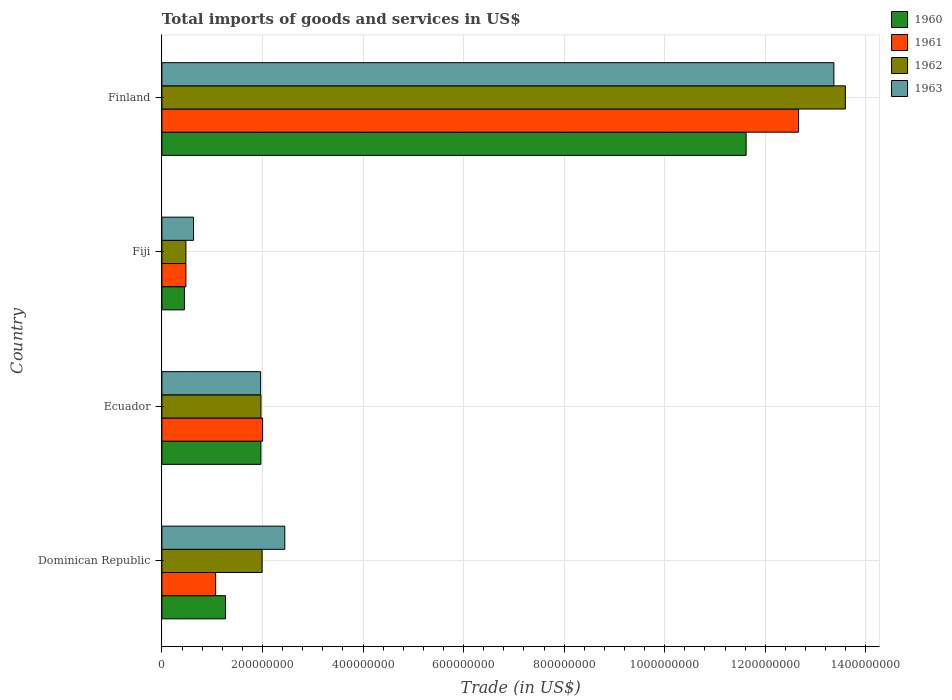How many groups of bars are there?
Offer a very short reply. 4. What is the total imports of goods and services in 1960 in Finland?
Give a very brief answer. 1.16e+09. Across all countries, what is the maximum total imports of goods and services in 1960?
Give a very brief answer. 1.16e+09. Across all countries, what is the minimum total imports of goods and services in 1961?
Your answer should be very brief. 4.77e+07. In which country was the total imports of goods and services in 1962 minimum?
Make the answer very short. Fiji. What is the total total imports of goods and services in 1961 in the graph?
Provide a short and direct response. 1.62e+09. What is the difference between the total imports of goods and services in 1960 in Dominican Republic and that in Finland?
Make the answer very short. -1.04e+09. What is the difference between the total imports of goods and services in 1960 in Fiji and the total imports of goods and services in 1961 in Ecuador?
Your answer should be compact. -1.55e+08. What is the average total imports of goods and services in 1960 per country?
Offer a very short reply. 3.83e+08. What is the difference between the total imports of goods and services in 1960 and total imports of goods and services in 1961 in Ecuador?
Provide a short and direct response. -3.37e+06. What is the ratio of the total imports of goods and services in 1961 in Ecuador to that in Fiji?
Offer a terse response. 4.2. Is the total imports of goods and services in 1962 in Fiji less than that in Finland?
Your answer should be compact. Yes. What is the difference between the highest and the second highest total imports of goods and services in 1962?
Your answer should be compact. 1.16e+09. What is the difference between the highest and the lowest total imports of goods and services in 1960?
Your answer should be very brief. 1.12e+09. In how many countries, is the total imports of goods and services in 1960 greater than the average total imports of goods and services in 1960 taken over all countries?
Give a very brief answer. 1. Is the sum of the total imports of goods and services in 1961 in Dominican Republic and Ecuador greater than the maximum total imports of goods and services in 1962 across all countries?
Keep it short and to the point. No. What does the 2nd bar from the bottom in Finland represents?
Offer a very short reply. 1961. How many bars are there?
Give a very brief answer. 16. Are all the bars in the graph horizontal?
Offer a terse response. Yes. How many countries are there in the graph?
Make the answer very short. 4. What is the difference between two consecutive major ticks on the X-axis?
Provide a short and direct response. 2.00e+08. Does the graph contain grids?
Make the answer very short. Yes. Where does the legend appear in the graph?
Give a very brief answer. Top right. What is the title of the graph?
Provide a short and direct response. Total imports of goods and services in US$. What is the label or title of the X-axis?
Make the answer very short. Trade (in US$). What is the Trade (in US$) of 1960 in Dominican Republic?
Offer a terse response. 1.26e+08. What is the Trade (in US$) of 1961 in Dominican Republic?
Provide a short and direct response. 1.07e+08. What is the Trade (in US$) in 1962 in Dominican Republic?
Give a very brief answer. 1.99e+08. What is the Trade (in US$) of 1963 in Dominican Republic?
Offer a terse response. 2.44e+08. What is the Trade (in US$) in 1960 in Ecuador?
Give a very brief answer. 1.97e+08. What is the Trade (in US$) of 1961 in Ecuador?
Your answer should be very brief. 2.00e+08. What is the Trade (in US$) of 1962 in Ecuador?
Ensure brevity in your answer.  1.97e+08. What is the Trade (in US$) in 1963 in Ecuador?
Provide a short and direct response. 1.96e+08. What is the Trade (in US$) of 1960 in Fiji?
Your response must be concise. 4.48e+07. What is the Trade (in US$) of 1961 in Fiji?
Provide a short and direct response. 4.77e+07. What is the Trade (in US$) in 1962 in Fiji?
Keep it short and to the point. 4.77e+07. What is the Trade (in US$) of 1963 in Fiji?
Provide a short and direct response. 6.30e+07. What is the Trade (in US$) of 1960 in Finland?
Ensure brevity in your answer.  1.16e+09. What is the Trade (in US$) in 1961 in Finland?
Offer a terse response. 1.27e+09. What is the Trade (in US$) of 1962 in Finland?
Offer a very short reply. 1.36e+09. What is the Trade (in US$) in 1963 in Finland?
Ensure brevity in your answer.  1.34e+09. Across all countries, what is the maximum Trade (in US$) in 1960?
Your answer should be compact. 1.16e+09. Across all countries, what is the maximum Trade (in US$) of 1961?
Offer a terse response. 1.27e+09. Across all countries, what is the maximum Trade (in US$) of 1962?
Offer a very short reply. 1.36e+09. Across all countries, what is the maximum Trade (in US$) in 1963?
Make the answer very short. 1.34e+09. Across all countries, what is the minimum Trade (in US$) in 1960?
Ensure brevity in your answer.  4.48e+07. Across all countries, what is the minimum Trade (in US$) in 1961?
Offer a terse response. 4.77e+07. Across all countries, what is the minimum Trade (in US$) of 1962?
Make the answer very short. 4.77e+07. Across all countries, what is the minimum Trade (in US$) in 1963?
Ensure brevity in your answer.  6.30e+07. What is the total Trade (in US$) in 1960 in the graph?
Keep it short and to the point. 1.53e+09. What is the total Trade (in US$) in 1961 in the graph?
Offer a terse response. 1.62e+09. What is the total Trade (in US$) of 1962 in the graph?
Offer a terse response. 1.80e+09. What is the total Trade (in US$) of 1963 in the graph?
Make the answer very short. 1.84e+09. What is the difference between the Trade (in US$) in 1960 in Dominican Republic and that in Ecuador?
Keep it short and to the point. -7.04e+07. What is the difference between the Trade (in US$) in 1961 in Dominican Republic and that in Ecuador?
Ensure brevity in your answer.  -9.34e+07. What is the difference between the Trade (in US$) in 1962 in Dominican Republic and that in Ecuador?
Your answer should be compact. 2.27e+06. What is the difference between the Trade (in US$) in 1963 in Dominican Republic and that in Ecuador?
Provide a succinct answer. 4.80e+07. What is the difference between the Trade (in US$) in 1960 in Dominican Republic and that in Fiji?
Make the answer very short. 8.17e+07. What is the difference between the Trade (in US$) in 1961 in Dominican Republic and that in Fiji?
Keep it short and to the point. 5.92e+07. What is the difference between the Trade (in US$) of 1962 in Dominican Republic and that in Fiji?
Make the answer very short. 1.52e+08. What is the difference between the Trade (in US$) of 1963 in Dominican Republic and that in Fiji?
Provide a succinct answer. 1.81e+08. What is the difference between the Trade (in US$) in 1960 in Dominican Republic and that in Finland?
Your answer should be very brief. -1.04e+09. What is the difference between the Trade (in US$) in 1961 in Dominican Republic and that in Finland?
Keep it short and to the point. -1.16e+09. What is the difference between the Trade (in US$) in 1962 in Dominican Republic and that in Finland?
Your response must be concise. -1.16e+09. What is the difference between the Trade (in US$) of 1963 in Dominican Republic and that in Finland?
Offer a very short reply. -1.09e+09. What is the difference between the Trade (in US$) of 1960 in Ecuador and that in Fiji?
Provide a short and direct response. 1.52e+08. What is the difference between the Trade (in US$) of 1961 in Ecuador and that in Fiji?
Ensure brevity in your answer.  1.53e+08. What is the difference between the Trade (in US$) of 1962 in Ecuador and that in Fiji?
Ensure brevity in your answer.  1.49e+08. What is the difference between the Trade (in US$) in 1963 in Ecuador and that in Fiji?
Offer a terse response. 1.33e+08. What is the difference between the Trade (in US$) of 1960 in Ecuador and that in Finland?
Your answer should be compact. -9.65e+08. What is the difference between the Trade (in US$) of 1961 in Ecuador and that in Finland?
Give a very brief answer. -1.07e+09. What is the difference between the Trade (in US$) in 1962 in Ecuador and that in Finland?
Make the answer very short. -1.16e+09. What is the difference between the Trade (in US$) in 1963 in Ecuador and that in Finland?
Your response must be concise. -1.14e+09. What is the difference between the Trade (in US$) of 1960 in Fiji and that in Finland?
Offer a very short reply. -1.12e+09. What is the difference between the Trade (in US$) of 1961 in Fiji and that in Finland?
Offer a very short reply. -1.22e+09. What is the difference between the Trade (in US$) of 1962 in Fiji and that in Finland?
Provide a short and direct response. -1.31e+09. What is the difference between the Trade (in US$) of 1963 in Fiji and that in Finland?
Give a very brief answer. -1.27e+09. What is the difference between the Trade (in US$) in 1960 in Dominican Republic and the Trade (in US$) in 1961 in Ecuador?
Your answer should be compact. -7.38e+07. What is the difference between the Trade (in US$) of 1960 in Dominican Republic and the Trade (in US$) of 1962 in Ecuador?
Keep it short and to the point. -7.05e+07. What is the difference between the Trade (in US$) of 1960 in Dominican Republic and the Trade (in US$) of 1963 in Ecuador?
Your response must be concise. -6.99e+07. What is the difference between the Trade (in US$) in 1961 in Dominican Republic and the Trade (in US$) in 1962 in Ecuador?
Give a very brief answer. -9.01e+07. What is the difference between the Trade (in US$) of 1961 in Dominican Republic and the Trade (in US$) of 1963 in Ecuador?
Keep it short and to the point. -8.95e+07. What is the difference between the Trade (in US$) of 1962 in Dominican Republic and the Trade (in US$) of 1963 in Ecuador?
Your answer should be compact. 2.94e+06. What is the difference between the Trade (in US$) of 1960 in Dominican Republic and the Trade (in US$) of 1961 in Fiji?
Ensure brevity in your answer.  7.88e+07. What is the difference between the Trade (in US$) in 1960 in Dominican Republic and the Trade (in US$) in 1962 in Fiji?
Your answer should be compact. 7.88e+07. What is the difference between the Trade (in US$) of 1960 in Dominican Republic and the Trade (in US$) of 1963 in Fiji?
Provide a succinct answer. 6.35e+07. What is the difference between the Trade (in US$) of 1961 in Dominican Republic and the Trade (in US$) of 1962 in Fiji?
Give a very brief answer. 5.92e+07. What is the difference between the Trade (in US$) of 1961 in Dominican Republic and the Trade (in US$) of 1963 in Fiji?
Offer a terse response. 4.39e+07. What is the difference between the Trade (in US$) in 1962 in Dominican Republic and the Trade (in US$) in 1963 in Fiji?
Make the answer very short. 1.36e+08. What is the difference between the Trade (in US$) in 1960 in Dominican Republic and the Trade (in US$) in 1961 in Finland?
Provide a succinct answer. -1.14e+09. What is the difference between the Trade (in US$) of 1960 in Dominican Republic and the Trade (in US$) of 1962 in Finland?
Offer a very short reply. -1.23e+09. What is the difference between the Trade (in US$) in 1960 in Dominican Republic and the Trade (in US$) in 1963 in Finland?
Provide a short and direct response. -1.21e+09. What is the difference between the Trade (in US$) in 1961 in Dominican Republic and the Trade (in US$) in 1962 in Finland?
Keep it short and to the point. -1.25e+09. What is the difference between the Trade (in US$) in 1961 in Dominican Republic and the Trade (in US$) in 1963 in Finland?
Your response must be concise. -1.23e+09. What is the difference between the Trade (in US$) in 1962 in Dominican Republic and the Trade (in US$) in 1963 in Finland?
Ensure brevity in your answer.  -1.14e+09. What is the difference between the Trade (in US$) of 1960 in Ecuador and the Trade (in US$) of 1961 in Fiji?
Your answer should be compact. 1.49e+08. What is the difference between the Trade (in US$) of 1960 in Ecuador and the Trade (in US$) of 1962 in Fiji?
Your answer should be very brief. 1.49e+08. What is the difference between the Trade (in US$) of 1960 in Ecuador and the Trade (in US$) of 1963 in Fiji?
Your answer should be compact. 1.34e+08. What is the difference between the Trade (in US$) of 1961 in Ecuador and the Trade (in US$) of 1962 in Fiji?
Keep it short and to the point. 1.53e+08. What is the difference between the Trade (in US$) in 1961 in Ecuador and the Trade (in US$) in 1963 in Fiji?
Make the answer very short. 1.37e+08. What is the difference between the Trade (in US$) of 1962 in Ecuador and the Trade (in US$) of 1963 in Fiji?
Ensure brevity in your answer.  1.34e+08. What is the difference between the Trade (in US$) of 1960 in Ecuador and the Trade (in US$) of 1961 in Finland?
Your answer should be compact. -1.07e+09. What is the difference between the Trade (in US$) of 1960 in Ecuador and the Trade (in US$) of 1962 in Finland?
Ensure brevity in your answer.  -1.16e+09. What is the difference between the Trade (in US$) in 1960 in Ecuador and the Trade (in US$) in 1963 in Finland?
Provide a short and direct response. -1.14e+09. What is the difference between the Trade (in US$) in 1961 in Ecuador and the Trade (in US$) in 1962 in Finland?
Give a very brief answer. -1.16e+09. What is the difference between the Trade (in US$) of 1961 in Ecuador and the Trade (in US$) of 1963 in Finland?
Offer a terse response. -1.14e+09. What is the difference between the Trade (in US$) in 1962 in Ecuador and the Trade (in US$) in 1963 in Finland?
Provide a succinct answer. -1.14e+09. What is the difference between the Trade (in US$) of 1960 in Fiji and the Trade (in US$) of 1961 in Finland?
Make the answer very short. -1.22e+09. What is the difference between the Trade (in US$) in 1960 in Fiji and the Trade (in US$) in 1962 in Finland?
Your response must be concise. -1.31e+09. What is the difference between the Trade (in US$) of 1960 in Fiji and the Trade (in US$) of 1963 in Finland?
Your response must be concise. -1.29e+09. What is the difference between the Trade (in US$) in 1961 in Fiji and the Trade (in US$) in 1962 in Finland?
Give a very brief answer. -1.31e+09. What is the difference between the Trade (in US$) of 1961 in Fiji and the Trade (in US$) of 1963 in Finland?
Provide a short and direct response. -1.29e+09. What is the difference between the Trade (in US$) of 1962 in Fiji and the Trade (in US$) of 1963 in Finland?
Provide a short and direct response. -1.29e+09. What is the average Trade (in US$) in 1960 per country?
Your answer should be very brief. 3.83e+08. What is the average Trade (in US$) in 1961 per country?
Keep it short and to the point. 4.05e+08. What is the average Trade (in US$) of 1962 per country?
Offer a terse response. 4.51e+08. What is the average Trade (in US$) of 1963 per country?
Offer a very short reply. 4.60e+08. What is the difference between the Trade (in US$) in 1960 and Trade (in US$) in 1961 in Dominican Republic?
Give a very brief answer. 1.96e+07. What is the difference between the Trade (in US$) in 1960 and Trade (in US$) in 1962 in Dominican Republic?
Ensure brevity in your answer.  -7.28e+07. What is the difference between the Trade (in US$) of 1960 and Trade (in US$) of 1963 in Dominican Republic?
Your answer should be compact. -1.18e+08. What is the difference between the Trade (in US$) in 1961 and Trade (in US$) in 1962 in Dominican Republic?
Your response must be concise. -9.24e+07. What is the difference between the Trade (in US$) of 1961 and Trade (in US$) of 1963 in Dominican Republic?
Provide a short and direct response. -1.38e+08. What is the difference between the Trade (in US$) in 1962 and Trade (in US$) in 1963 in Dominican Republic?
Provide a succinct answer. -4.51e+07. What is the difference between the Trade (in US$) of 1960 and Trade (in US$) of 1961 in Ecuador?
Ensure brevity in your answer.  -3.37e+06. What is the difference between the Trade (in US$) of 1960 and Trade (in US$) of 1962 in Ecuador?
Give a very brief answer. -1.34e+05. What is the difference between the Trade (in US$) of 1960 and Trade (in US$) of 1963 in Ecuador?
Your response must be concise. 5.38e+05. What is the difference between the Trade (in US$) of 1961 and Trade (in US$) of 1962 in Ecuador?
Give a very brief answer. 3.24e+06. What is the difference between the Trade (in US$) in 1961 and Trade (in US$) in 1963 in Ecuador?
Provide a succinct answer. 3.91e+06. What is the difference between the Trade (in US$) of 1962 and Trade (in US$) of 1963 in Ecuador?
Keep it short and to the point. 6.72e+05. What is the difference between the Trade (in US$) in 1960 and Trade (in US$) in 1961 in Fiji?
Your response must be concise. -2.90e+06. What is the difference between the Trade (in US$) of 1960 and Trade (in US$) of 1962 in Fiji?
Offer a terse response. -2.90e+06. What is the difference between the Trade (in US$) in 1960 and Trade (in US$) in 1963 in Fiji?
Provide a succinct answer. -1.81e+07. What is the difference between the Trade (in US$) in 1961 and Trade (in US$) in 1962 in Fiji?
Offer a very short reply. 0. What is the difference between the Trade (in US$) in 1961 and Trade (in US$) in 1963 in Fiji?
Your answer should be very brief. -1.52e+07. What is the difference between the Trade (in US$) of 1962 and Trade (in US$) of 1963 in Fiji?
Give a very brief answer. -1.52e+07. What is the difference between the Trade (in US$) of 1960 and Trade (in US$) of 1961 in Finland?
Your answer should be very brief. -1.04e+08. What is the difference between the Trade (in US$) of 1960 and Trade (in US$) of 1962 in Finland?
Make the answer very short. -1.97e+08. What is the difference between the Trade (in US$) of 1960 and Trade (in US$) of 1963 in Finland?
Provide a short and direct response. -1.75e+08. What is the difference between the Trade (in US$) of 1961 and Trade (in US$) of 1962 in Finland?
Make the answer very short. -9.31e+07. What is the difference between the Trade (in US$) of 1961 and Trade (in US$) of 1963 in Finland?
Keep it short and to the point. -7.02e+07. What is the difference between the Trade (in US$) of 1962 and Trade (in US$) of 1963 in Finland?
Your response must be concise. 2.29e+07. What is the ratio of the Trade (in US$) of 1960 in Dominican Republic to that in Ecuador?
Your response must be concise. 0.64. What is the ratio of the Trade (in US$) in 1961 in Dominican Republic to that in Ecuador?
Ensure brevity in your answer.  0.53. What is the ratio of the Trade (in US$) in 1962 in Dominican Republic to that in Ecuador?
Give a very brief answer. 1.01. What is the ratio of the Trade (in US$) in 1963 in Dominican Republic to that in Ecuador?
Ensure brevity in your answer.  1.24. What is the ratio of the Trade (in US$) of 1960 in Dominican Republic to that in Fiji?
Keep it short and to the point. 2.82. What is the ratio of the Trade (in US$) in 1961 in Dominican Republic to that in Fiji?
Give a very brief answer. 2.24. What is the ratio of the Trade (in US$) of 1962 in Dominican Republic to that in Fiji?
Your answer should be very brief. 4.18. What is the ratio of the Trade (in US$) in 1963 in Dominican Republic to that in Fiji?
Offer a very short reply. 3.88. What is the ratio of the Trade (in US$) in 1960 in Dominican Republic to that in Finland?
Your response must be concise. 0.11. What is the ratio of the Trade (in US$) in 1961 in Dominican Republic to that in Finland?
Provide a short and direct response. 0.08. What is the ratio of the Trade (in US$) of 1962 in Dominican Republic to that in Finland?
Keep it short and to the point. 0.15. What is the ratio of the Trade (in US$) of 1963 in Dominican Republic to that in Finland?
Your answer should be compact. 0.18. What is the ratio of the Trade (in US$) in 1960 in Ecuador to that in Fiji?
Your response must be concise. 4.39. What is the ratio of the Trade (in US$) of 1961 in Ecuador to that in Fiji?
Your answer should be compact. 4.2. What is the ratio of the Trade (in US$) of 1962 in Ecuador to that in Fiji?
Your answer should be compact. 4.13. What is the ratio of the Trade (in US$) of 1963 in Ecuador to that in Fiji?
Your answer should be very brief. 3.12. What is the ratio of the Trade (in US$) in 1960 in Ecuador to that in Finland?
Your answer should be compact. 0.17. What is the ratio of the Trade (in US$) in 1961 in Ecuador to that in Finland?
Offer a terse response. 0.16. What is the ratio of the Trade (in US$) of 1962 in Ecuador to that in Finland?
Provide a succinct answer. 0.14. What is the ratio of the Trade (in US$) of 1963 in Ecuador to that in Finland?
Provide a short and direct response. 0.15. What is the ratio of the Trade (in US$) in 1960 in Fiji to that in Finland?
Your answer should be very brief. 0.04. What is the ratio of the Trade (in US$) of 1961 in Fiji to that in Finland?
Offer a terse response. 0.04. What is the ratio of the Trade (in US$) in 1962 in Fiji to that in Finland?
Your answer should be compact. 0.04. What is the ratio of the Trade (in US$) in 1963 in Fiji to that in Finland?
Offer a very short reply. 0.05. What is the difference between the highest and the second highest Trade (in US$) in 1960?
Offer a very short reply. 9.65e+08. What is the difference between the highest and the second highest Trade (in US$) of 1961?
Keep it short and to the point. 1.07e+09. What is the difference between the highest and the second highest Trade (in US$) of 1962?
Your answer should be compact. 1.16e+09. What is the difference between the highest and the second highest Trade (in US$) in 1963?
Ensure brevity in your answer.  1.09e+09. What is the difference between the highest and the lowest Trade (in US$) in 1960?
Offer a very short reply. 1.12e+09. What is the difference between the highest and the lowest Trade (in US$) in 1961?
Offer a terse response. 1.22e+09. What is the difference between the highest and the lowest Trade (in US$) of 1962?
Your response must be concise. 1.31e+09. What is the difference between the highest and the lowest Trade (in US$) of 1963?
Give a very brief answer. 1.27e+09. 